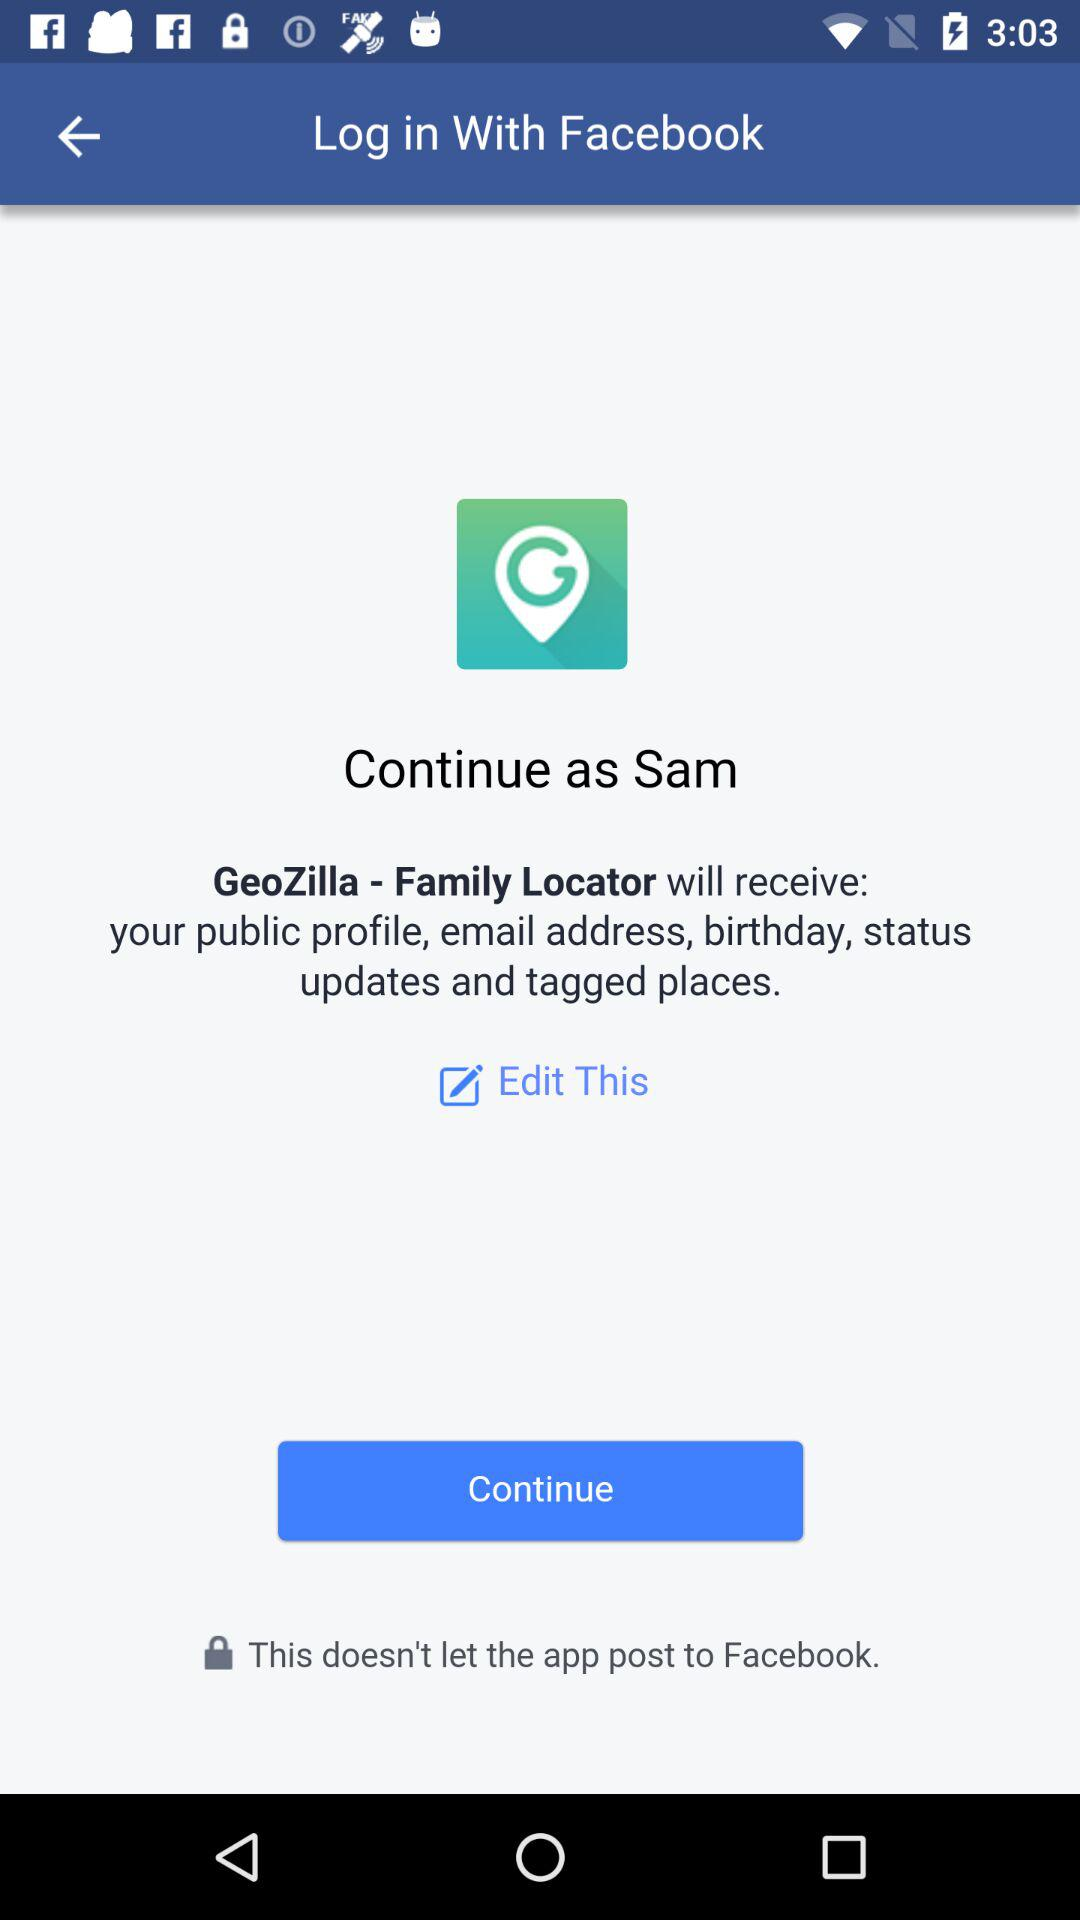What is the name of the user? The name of the user is Sam. 